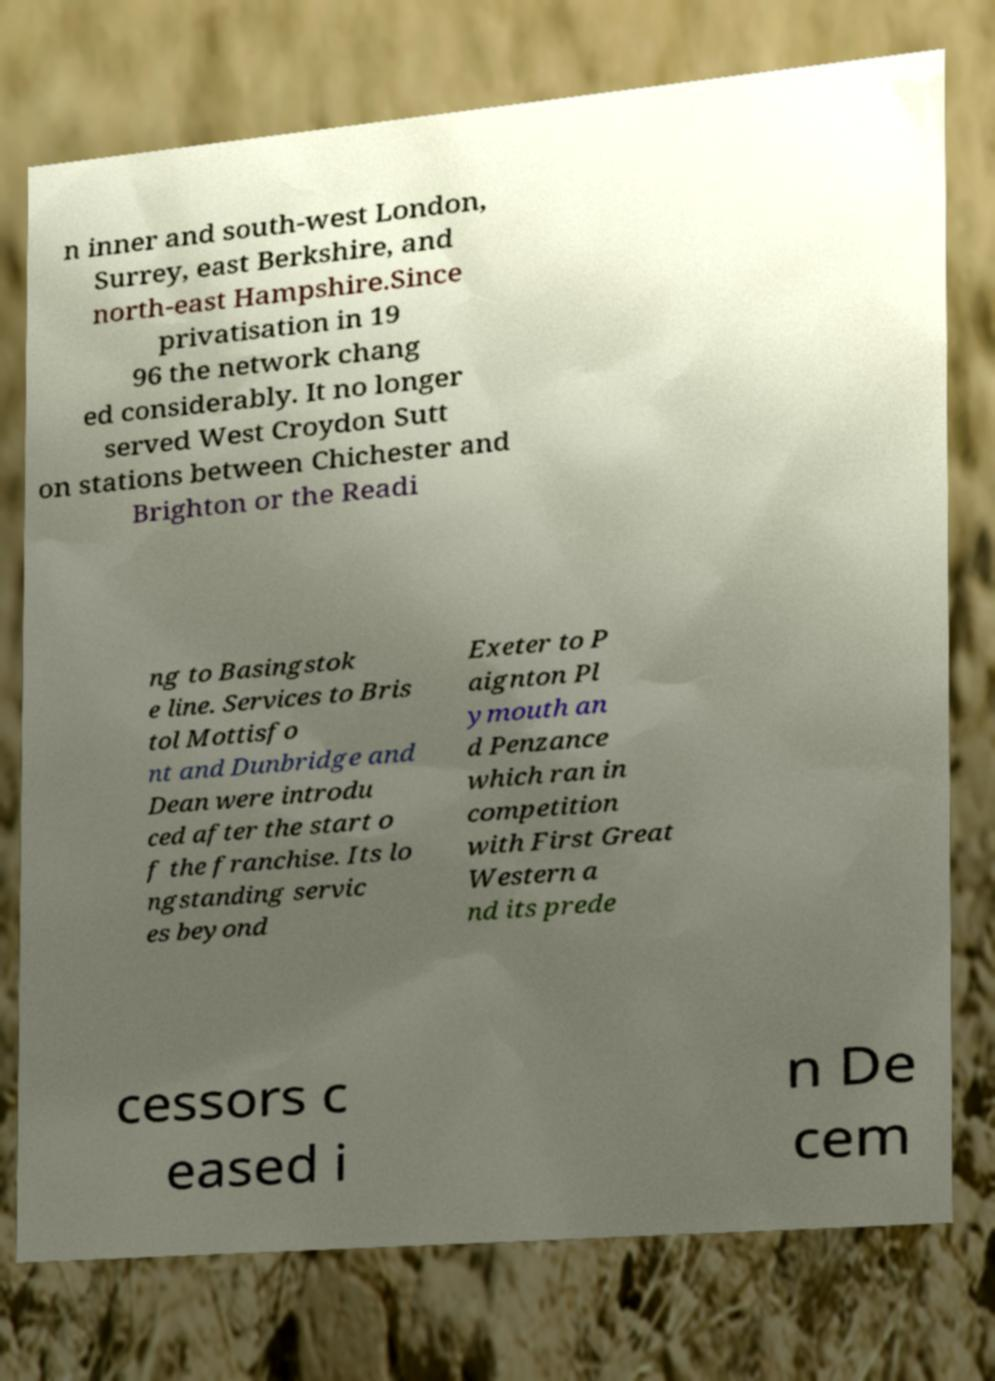Could you extract and type out the text from this image? n inner and south-west London, Surrey, east Berkshire, and north-east Hampshire.Since privatisation in 19 96 the network chang ed considerably. It no longer served West Croydon Sutt on stations between Chichester and Brighton or the Readi ng to Basingstok e line. Services to Bris tol Mottisfo nt and Dunbridge and Dean were introdu ced after the start o f the franchise. Its lo ngstanding servic es beyond Exeter to P aignton Pl ymouth an d Penzance which ran in competition with First Great Western a nd its prede cessors c eased i n De cem 